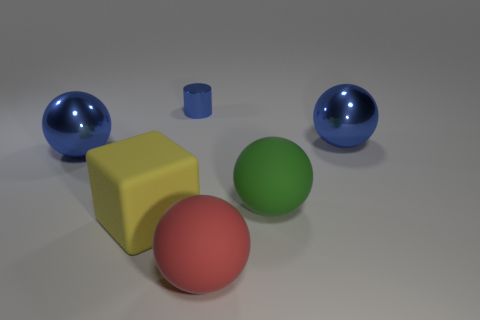Do the small blue cylinder and the big green thing have the same material?
Ensure brevity in your answer.  No. There is another matte sphere that is the same size as the green rubber ball; what color is it?
Give a very brief answer. Red. There is a shiny object that is both in front of the small cylinder and left of the large red matte object; what color is it?
Provide a succinct answer. Blue. What is the size of the yellow rubber cube that is in front of the blue ball that is behind the big thing that is on the left side of the big yellow cube?
Offer a very short reply. Large. What material is the cube?
Offer a terse response. Rubber. Are the red ball and the big blue thing that is left of the blue metallic cylinder made of the same material?
Provide a succinct answer. No. Is there any other thing of the same color as the tiny thing?
Keep it short and to the point. Yes. There is a blue thing that is in front of the big blue shiny object that is right of the green rubber object; is there a cylinder that is to the left of it?
Provide a short and direct response. No. The cylinder is what color?
Your answer should be compact. Blue. There is a green ball; are there any yellow things right of it?
Give a very brief answer. No. 